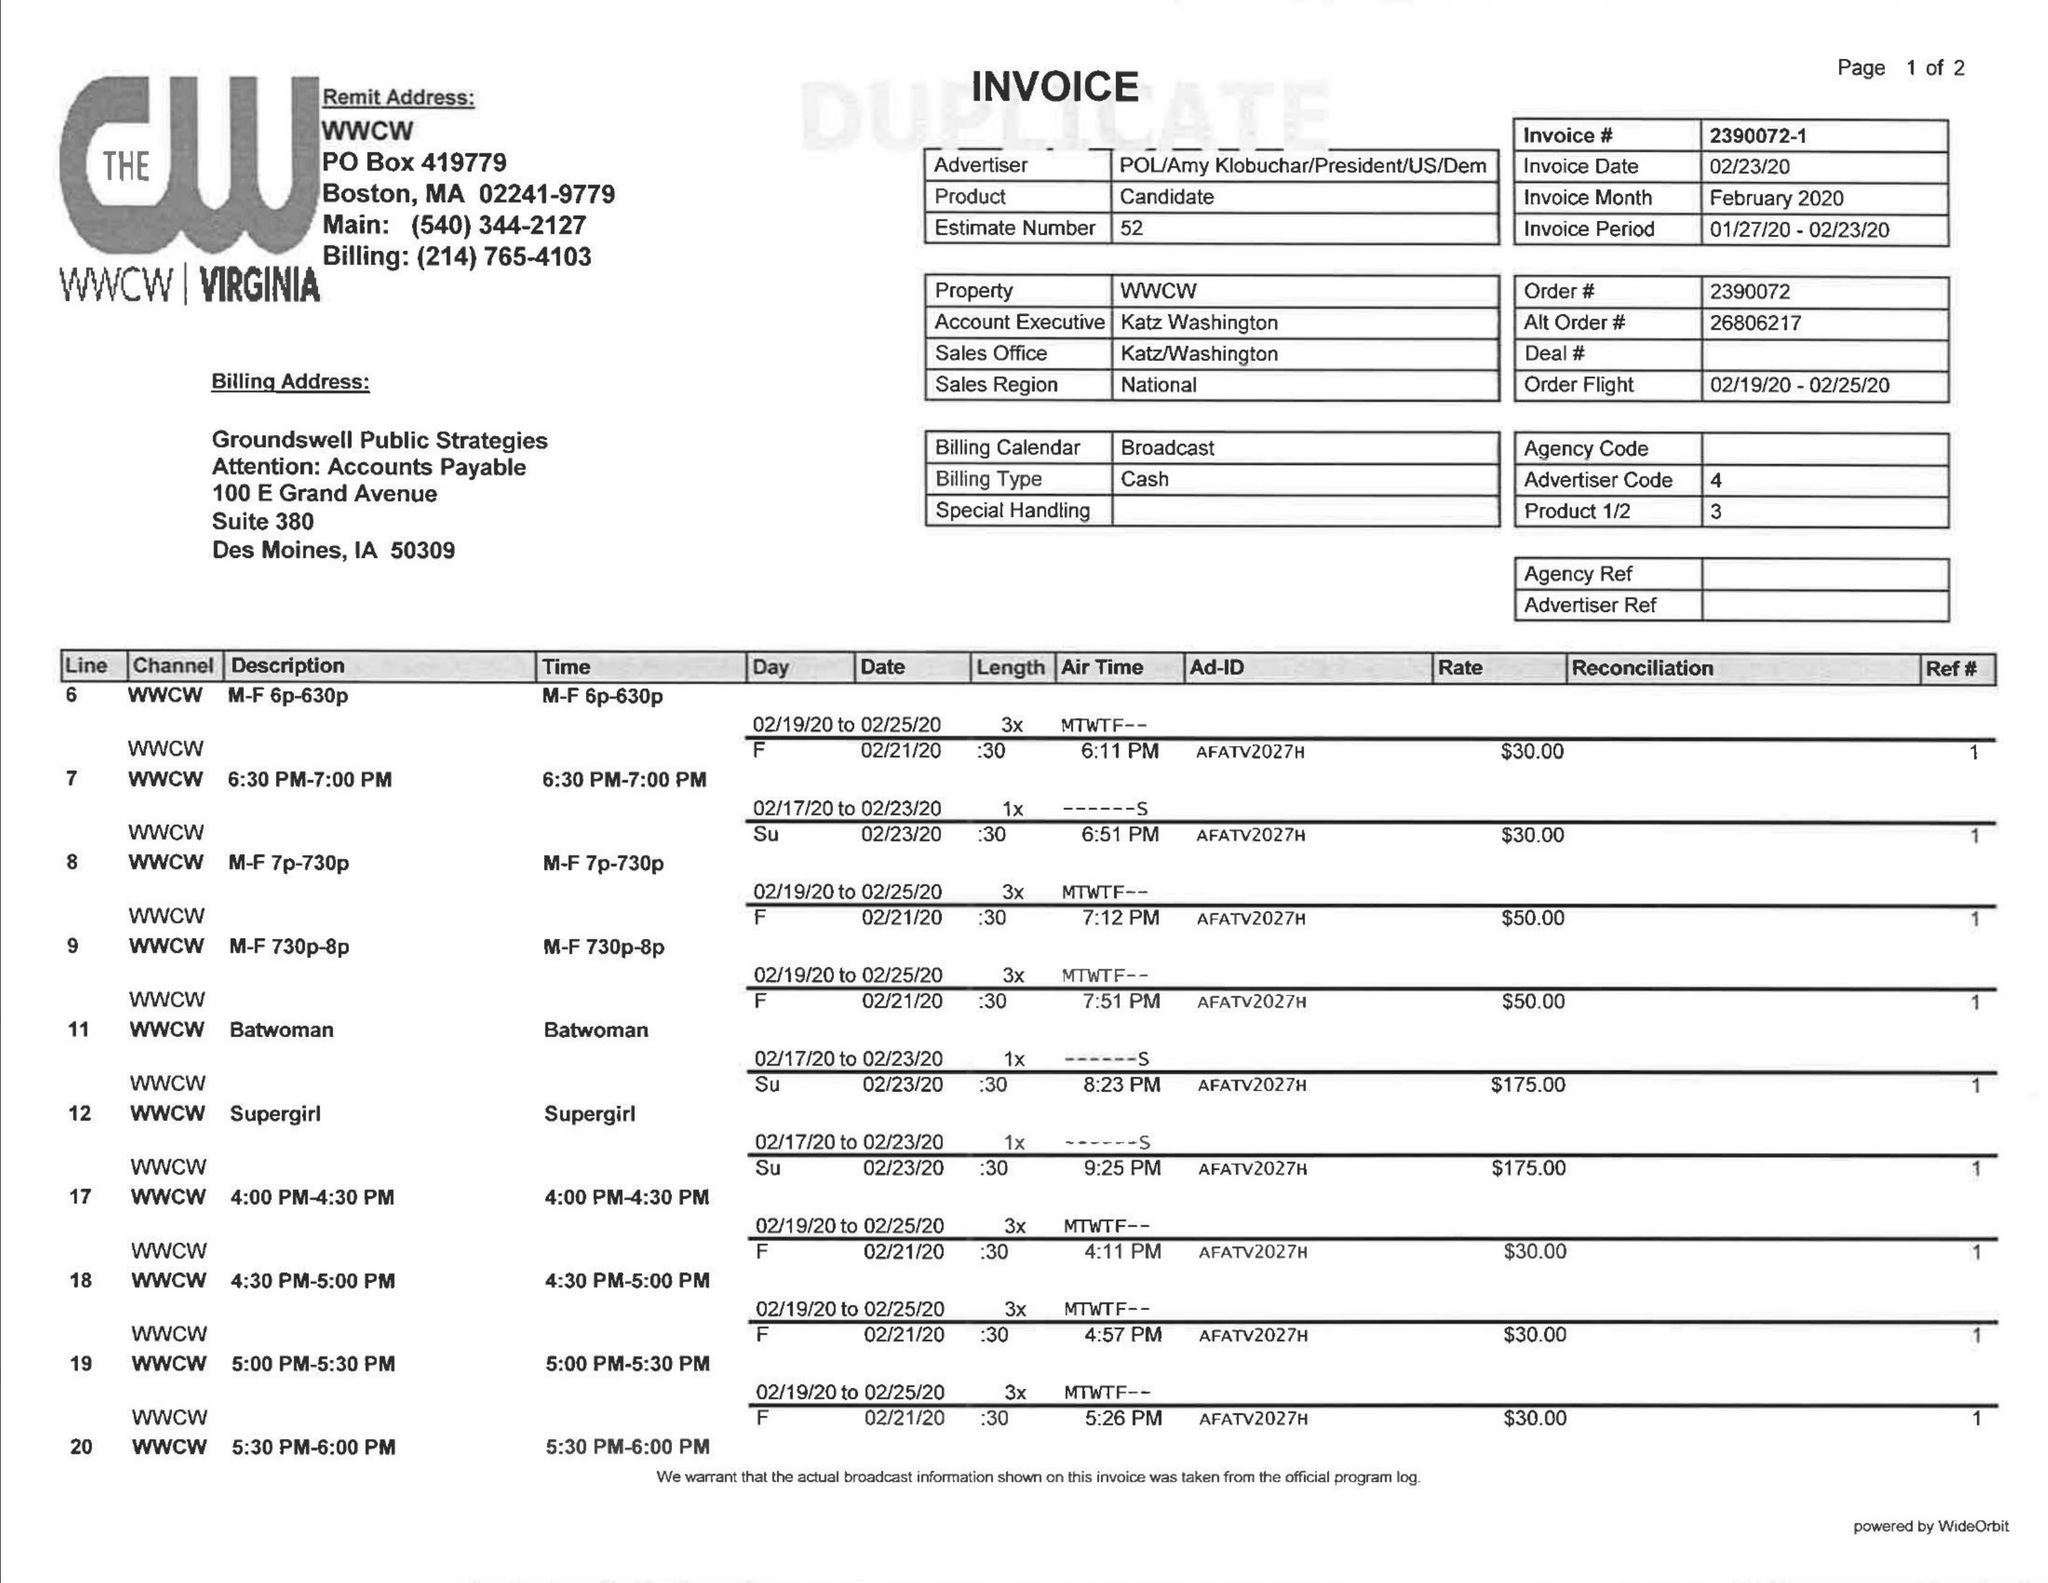What is the value for the flight_to?
Answer the question using a single word or phrase. 02/23/20 